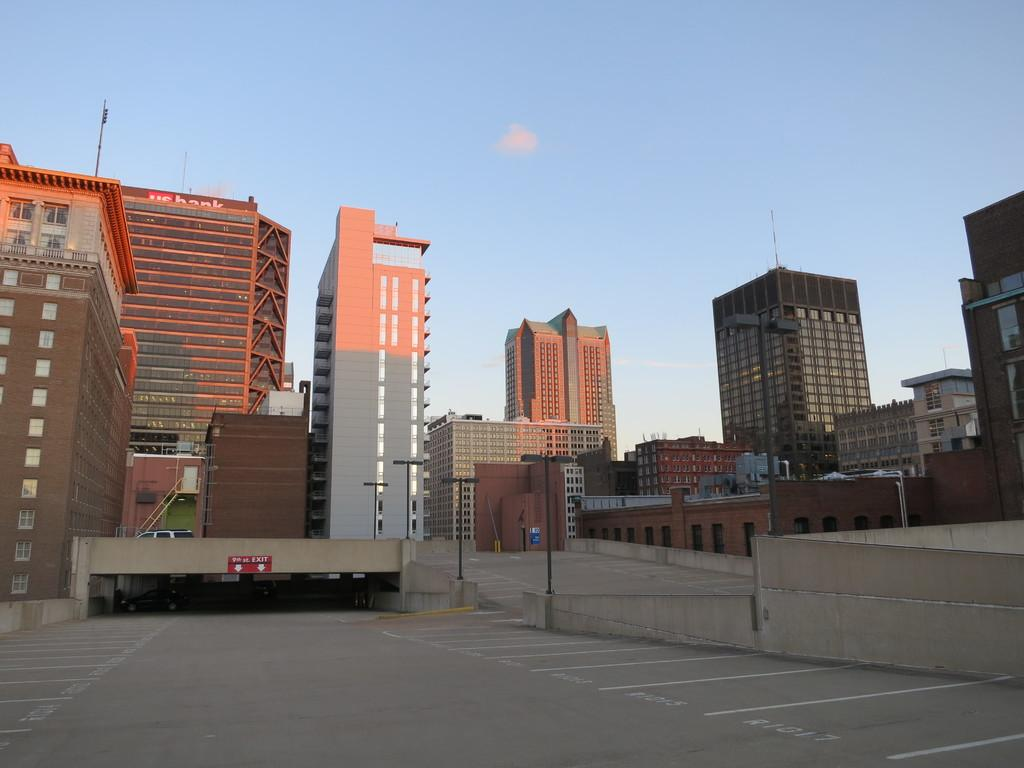What types of man-made structures can be seen in the image? There are vehicles, buildings, and poles in the image. What else can be seen in the image besides structures? There are lights in the image. What is visible in the background of the image? The sky is visible in the background of the image. How many hands are visible in the image? There are no hands visible in the image. What type of bead is used to decorate the buildings in the image? There are no beads used to decorate the buildings in the image. 